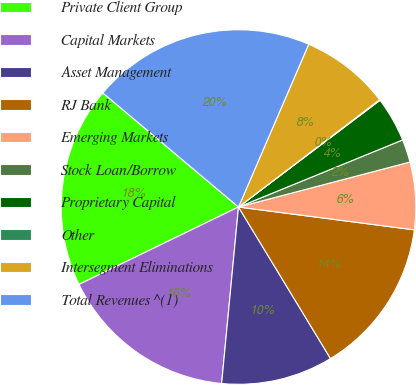Convert chart. <chart><loc_0><loc_0><loc_500><loc_500><pie_chart><fcel>Private Client Group<fcel>Capital Markets<fcel>Asset Management<fcel>RJ Bank<fcel>Emerging Markets<fcel>Stock Loan/Borrow<fcel>Proprietary Capital<fcel>Other<fcel>Intersegment Eliminations<fcel>Total Revenues ^(1)<nl><fcel>18.32%<fcel>16.29%<fcel>10.2%<fcel>14.26%<fcel>6.14%<fcel>2.09%<fcel>4.11%<fcel>0.06%<fcel>8.17%<fcel>20.35%<nl></chart> 